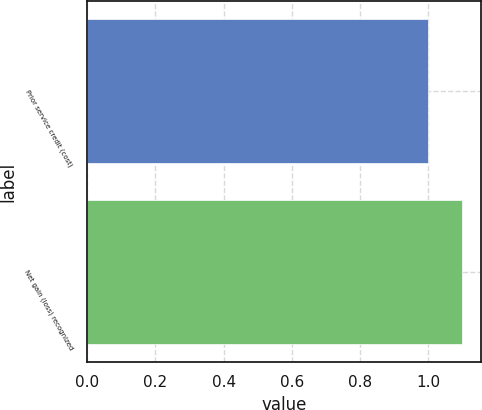<chart> <loc_0><loc_0><loc_500><loc_500><bar_chart><fcel>Prior service credit (cost)<fcel>Net gain (loss) recognized<nl><fcel>1<fcel>1.1<nl></chart> 